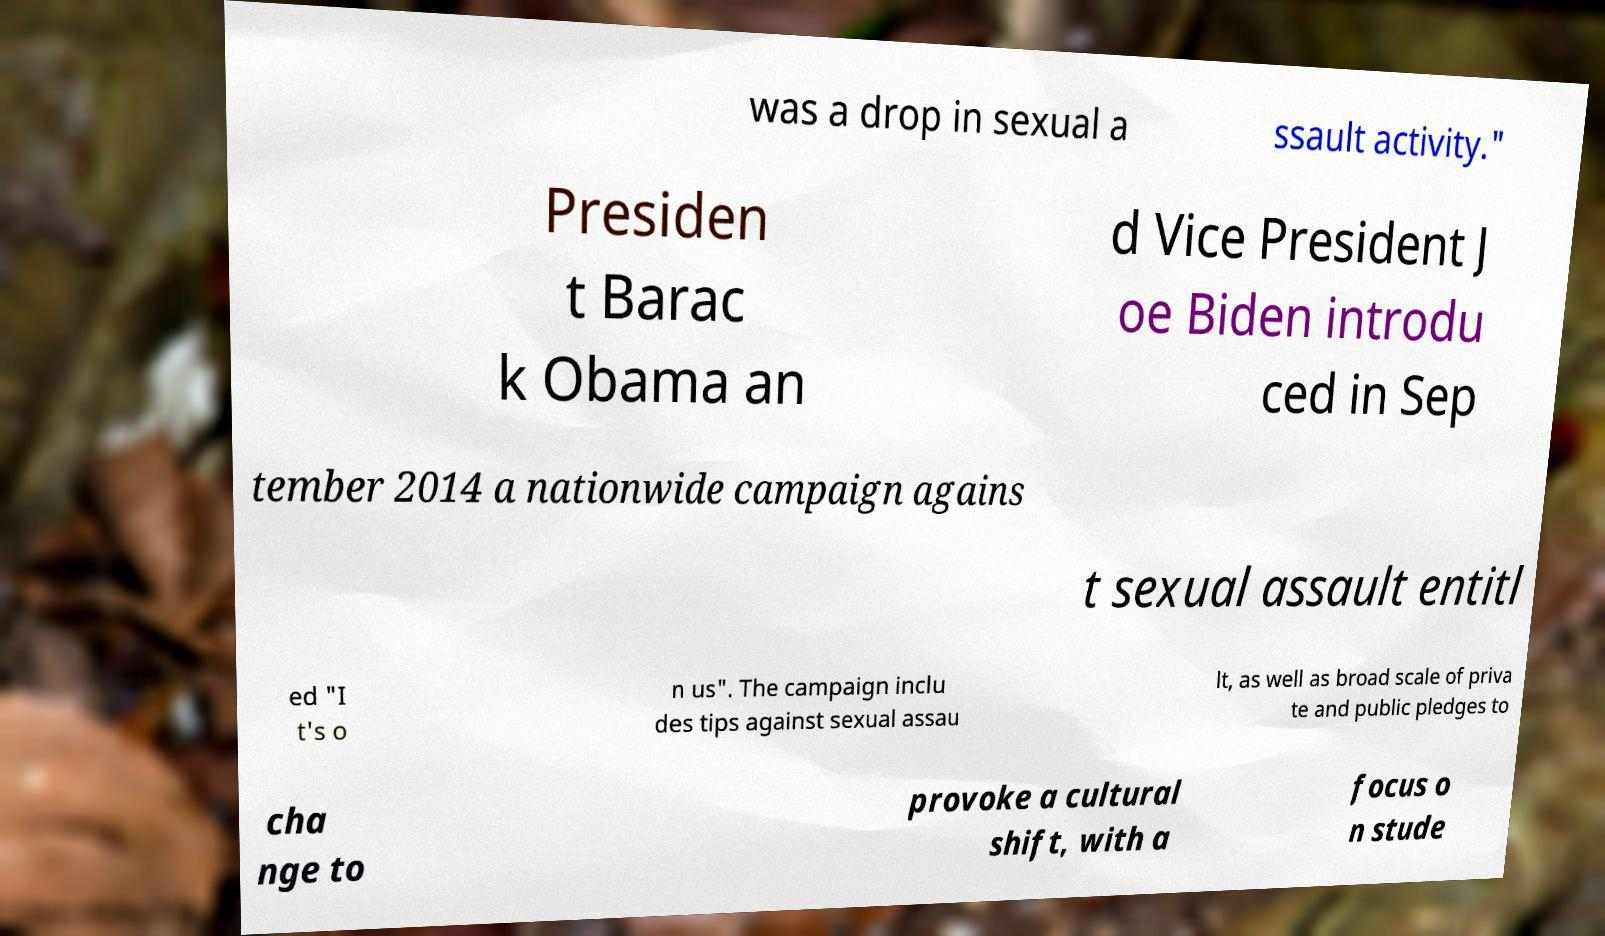Please identify and transcribe the text found in this image. was a drop in sexual a ssault activity." Presiden t Barac k Obama an d Vice President J oe Biden introdu ced in Sep tember 2014 a nationwide campaign agains t sexual assault entitl ed "I t's o n us". The campaign inclu des tips against sexual assau lt, as well as broad scale of priva te and public pledges to cha nge to provoke a cultural shift, with a focus o n stude 